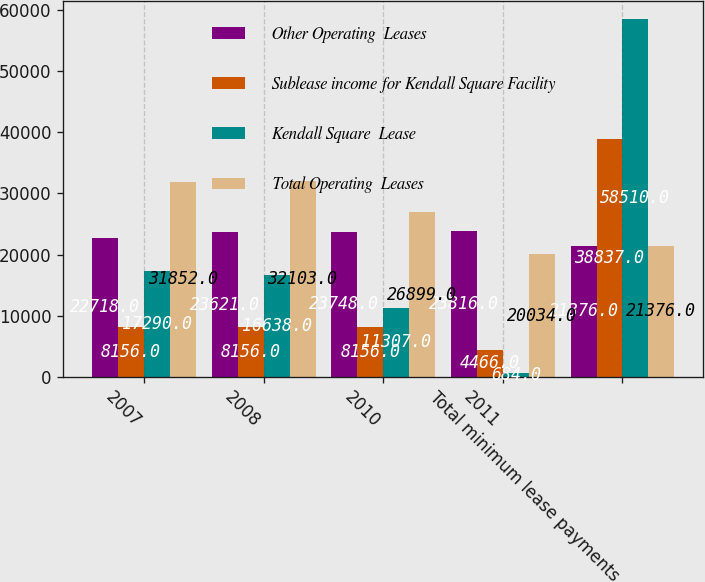Convert chart. <chart><loc_0><loc_0><loc_500><loc_500><stacked_bar_chart><ecel><fcel>2007<fcel>2008<fcel>2010<fcel>2011<fcel>Total minimum lease payments<nl><fcel>Other Operating  Leases<fcel>22718<fcel>23621<fcel>23748<fcel>23816<fcel>21376<nl><fcel>Sublease income for Kendall Square Facility<fcel>8156<fcel>8156<fcel>8156<fcel>4466<fcel>38837<nl><fcel>Kendall Square  Lease<fcel>17290<fcel>16638<fcel>11307<fcel>684<fcel>58510<nl><fcel>Total Operating  Leases<fcel>31852<fcel>32103<fcel>26899<fcel>20034<fcel>21376<nl></chart> 